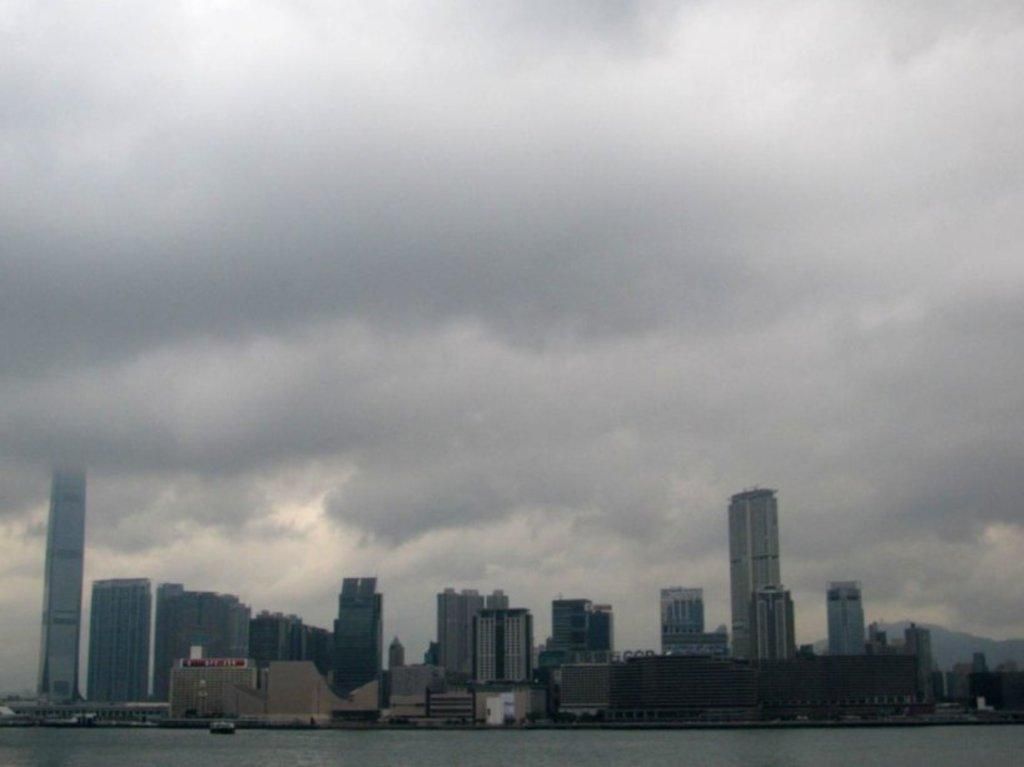What type of structures can be seen in the image? There are buildings in the image. What is visible at the bottom of the image? There is water visible at the bottom of the image. What can be seen in the sky at the top of the image? There are clouds in the sky at the top of the image. What type of fiction is being celebrated in the image? There is no indication of a fiction celebration in the image; it features buildings, water, and clouds. Whose birthday is being celebrated in the image? There is no indication of a birthday celebration in the image; it features buildings, water, and clouds. 